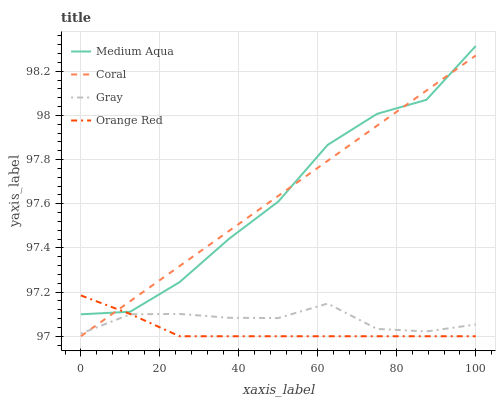Does Orange Red have the minimum area under the curve?
Answer yes or no. Yes. Does Coral have the maximum area under the curve?
Answer yes or no. Yes. Does Medium Aqua have the minimum area under the curve?
Answer yes or no. No. Does Medium Aqua have the maximum area under the curve?
Answer yes or no. No. Is Coral the smoothest?
Answer yes or no. Yes. Is Medium Aqua the roughest?
Answer yes or no. Yes. Is Medium Aqua the smoothest?
Answer yes or no. No. Is Coral the roughest?
Answer yes or no. No. Does Coral have the lowest value?
Answer yes or no. Yes. Does Medium Aqua have the lowest value?
Answer yes or no. No. Does Medium Aqua have the highest value?
Answer yes or no. Yes. Does Coral have the highest value?
Answer yes or no. No. Is Gray less than Medium Aqua?
Answer yes or no. Yes. Is Medium Aqua greater than Gray?
Answer yes or no. Yes. Does Medium Aqua intersect Orange Red?
Answer yes or no. Yes. Is Medium Aqua less than Orange Red?
Answer yes or no. No. Is Medium Aqua greater than Orange Red?
Answer yes or no. No. Does Gray intersect Medium Aqua?
Answer yes or no. No. 